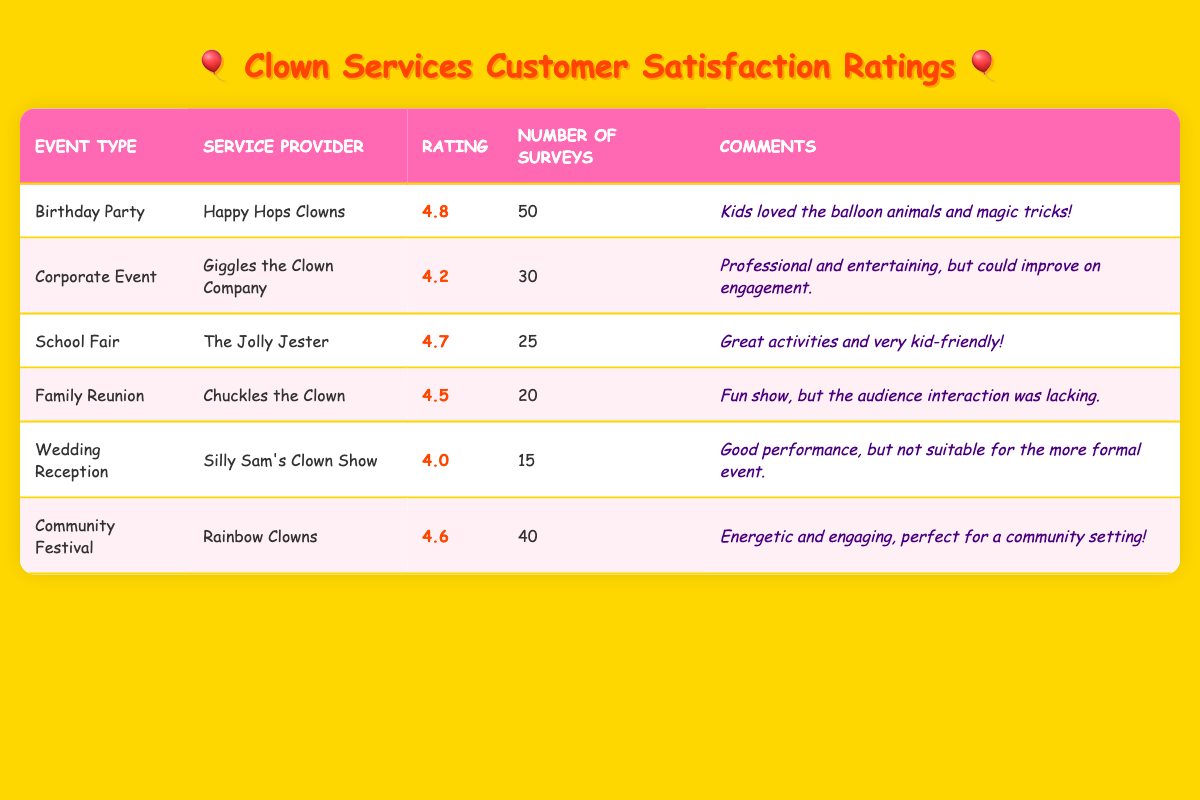what is the highest rating among the clown services? The highest rating in the table is 4.8, which is associated with the "Birthday Party" service provided by "Happy Hops Clowns."
Answer: 4.8 how many surveys were conducted for the "Community Festival" event? The number of surveys conducted for the "Community Festival" is 40, as listed in the table.
Answer: 40 what is the average rating for clown services based on the given data? To find the average, we sum the ratings: (4.8 + 4.2 + 4.7 + 4.5 + 4.0 + 4.6) = 26.8. There are 6 ratings, so the average is 26.8 / 6 = 4.47.
Answer: 4.47 did the "Silly Sam's Clown Show" receive a higher rating than "Chuckles the Clown"? "Silly Sam's Clown Show" has a rating of 4.0, while "Chuckles the Clown" has a rating of 4.5. Since 4.0 is less than 4.5, the claim is false.
Answer: No which service provider has the most surveys completed? "Happy Hops Clowns" has the most surveys completed with a total of 50, as shown in the table.
Answer: Happy Hops Clowns if we combine the ratings of "Corporate Event" and "Family Reunion," what is their total? The rating for "Corporate Event" is 4.2 and for "Family Reunion" it is 4.5. Adding these gives us 4.2 + 4.5 = 8.7.
Answer: 8.7 is there a service provider that specializes in both birthday parties and school fairs? "Happy Hops Clowns" specializes in "Birthday Party" and "The Jolly Jester" specializes in "School Fair." There is no overlap in service providers, so the answer is no.
Answer: No what type of event received the lowest rating? The "Wedding Reception" received the lowest rating of 4.0, as detailed in the table.
Answer: Wedding Reception what is the difference in ratings between "The Jolly Jester" and "Giggles the Clown Company"? "The Jolly Jester" has a rating of 4.7, while "Giggles the Clown Company" has a rating of 4.2. The difference is calculated as 4.7 - 4.2 = 0.5.
Answer: 0.5 